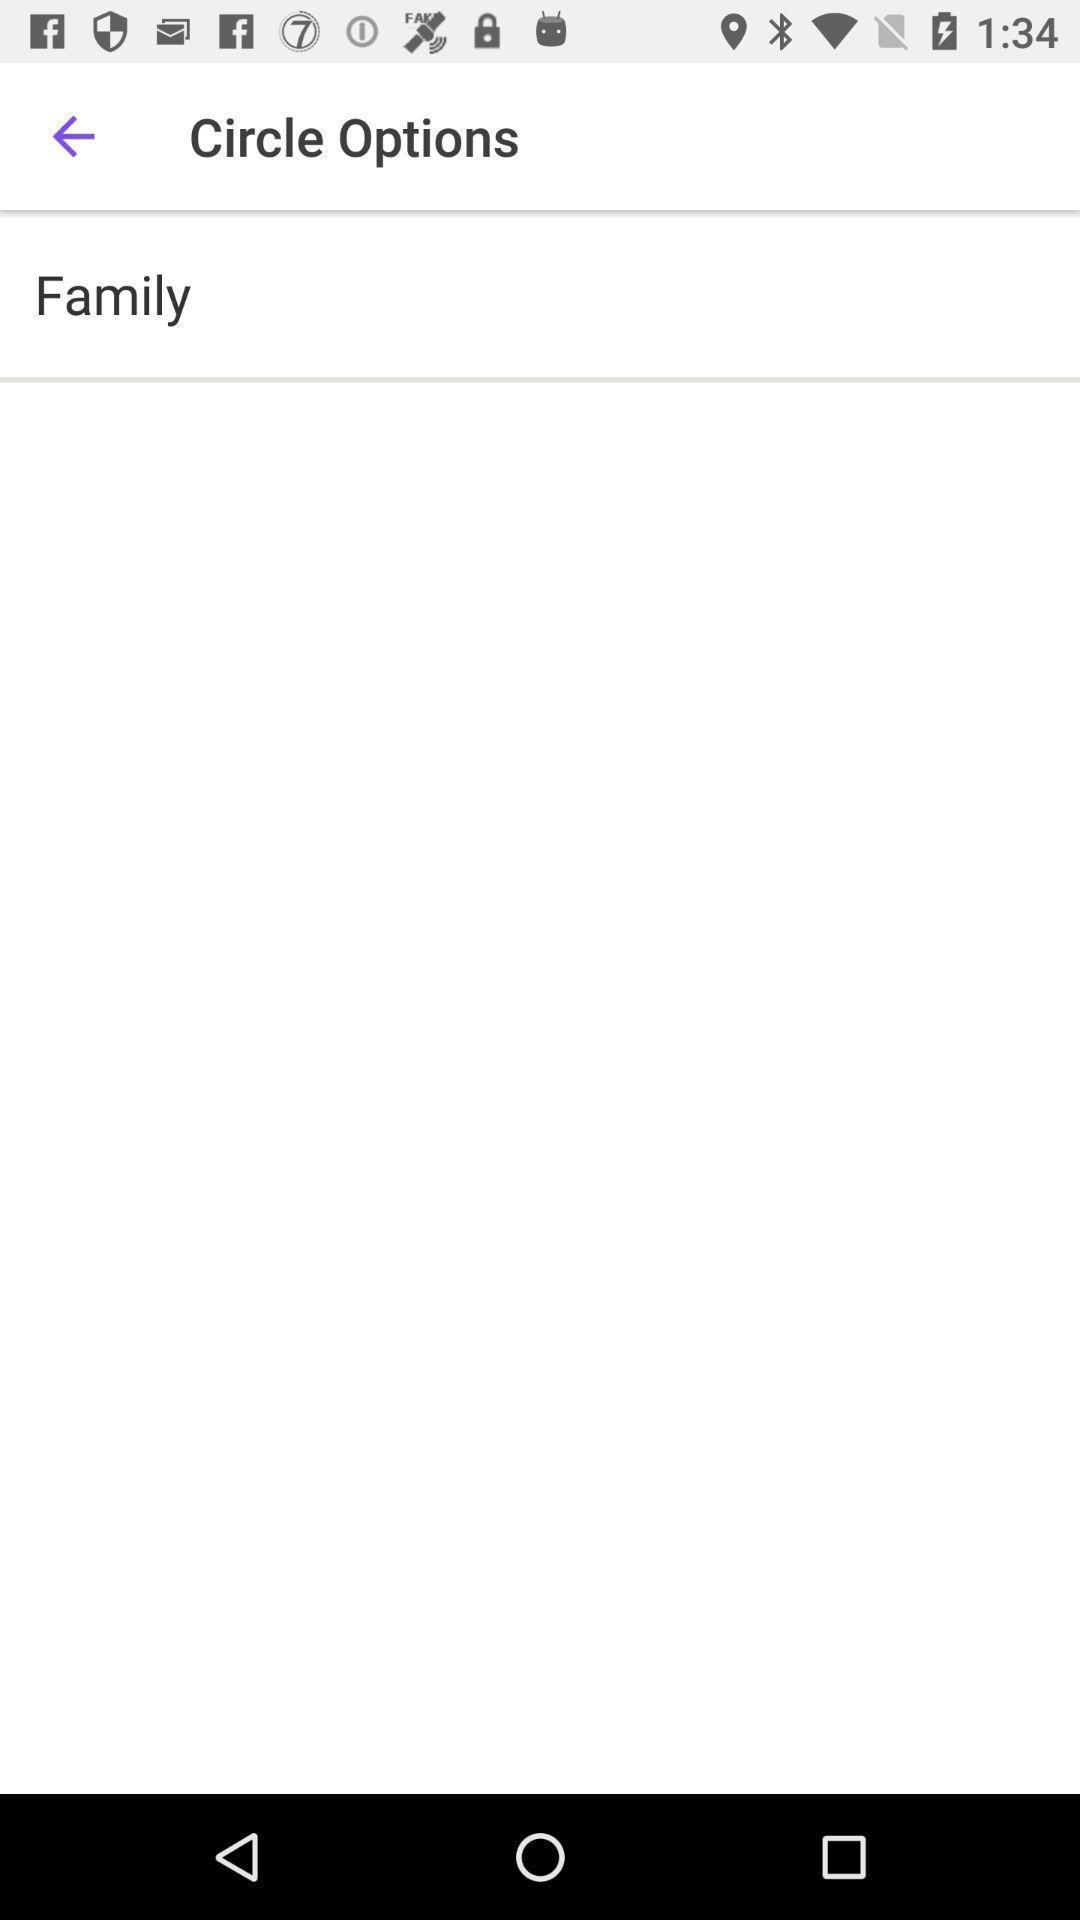Give me a summary of this screen capture. Page displaying the circle options. 